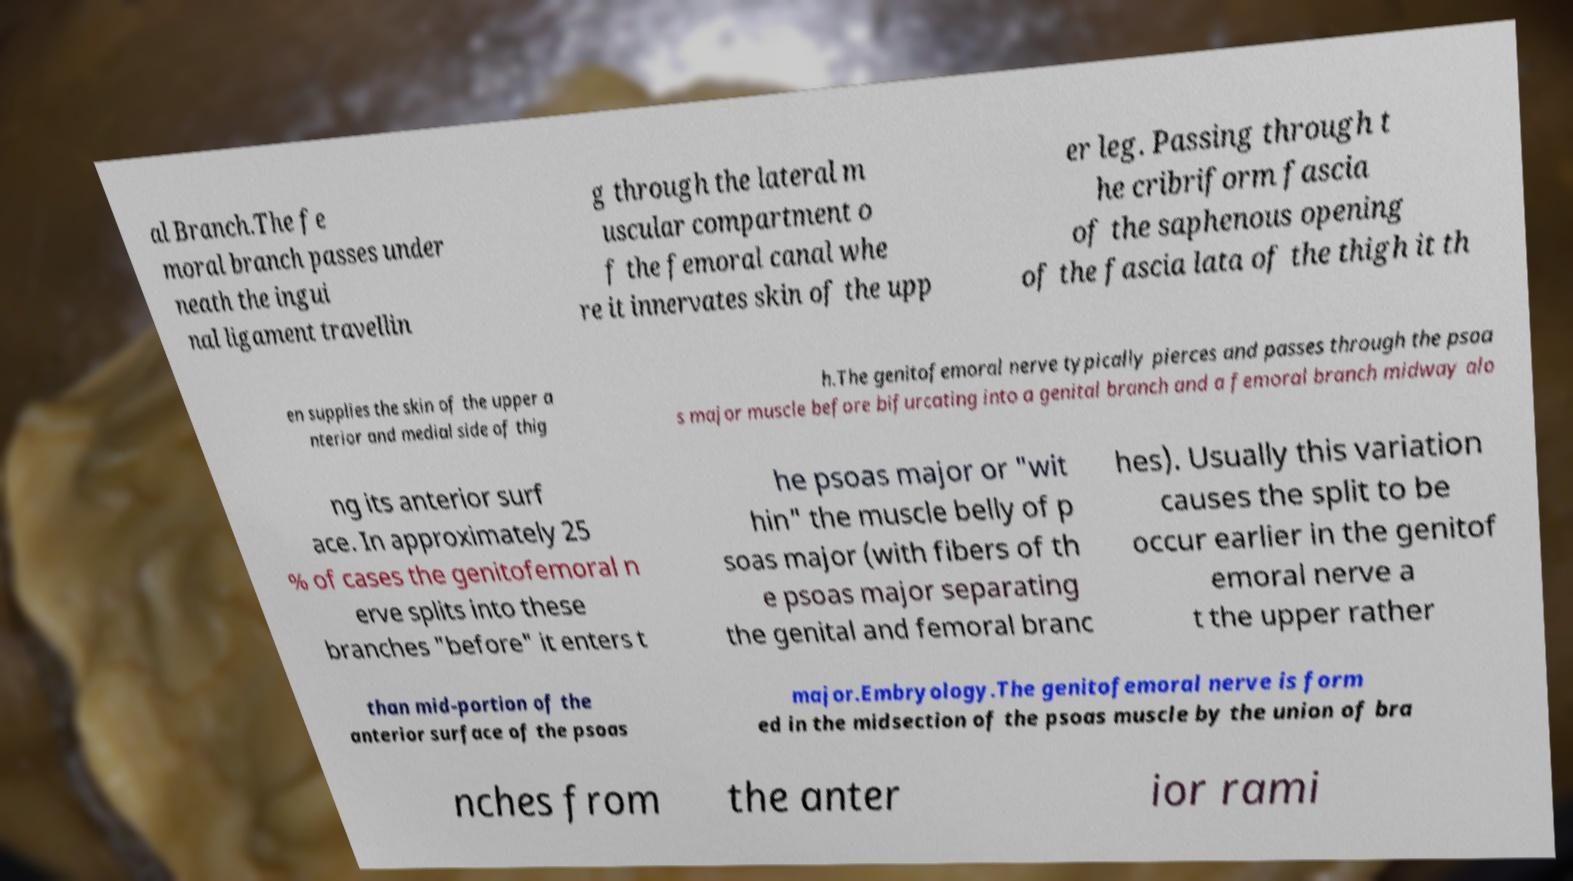I need the written content from this picture converted into text. Can you do that? al Branch.The fe moral branch passes under neath the ingui nal ligament travellin g through the lateral m uscular compartment o f the femoral canal whe re it innervates skin of the upp er leg. Passing through t he cribriform fascia of the saphenous opening of the fascia lata of the thigh it th en supplies the skin of the upper a nterior and medial side of thig h.The genitofemoral nerve typically pierces and passes through the psoa s major muscle before bifurcating into a genital branch and a femoral branch midway alo ng its anterior surf ace. In approximately 25 % of cases the genitofemoral n erve splits into these branches "before" it enters t he psoas major or "wit hin" the muscle belly of p soas major (with fibers of th e psoas major separating the genital and femoral branc hes). Usually this variation causes the split to be occur earlier in the genitof emoral nerve a t the upper rather than mid-portion of the anterior surface of the psoas major.Embryology.The genitofemoral nerve is form ed in the midsection of the psoas muscle by the union of bra nches from the anter ior rami 